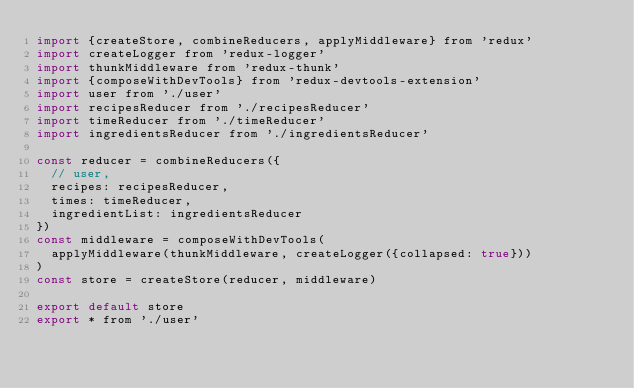Convert code to text. <code><loc_0><loc_0><loc_500><loc_500><_JavaScript_>import {createStore, combineReducers, applyMiddleware} from 'redux'
import createLogger from 'redux-logger'
import thunkMiddleware from 'redux-thunk'
import {composeWithDevTools} from 'redux-devtools-extension'
import user from './user'
import recipesReducer from './recipesReducer'
import timeReducer from './timeReducer'
import ingredientsReducer from './ingredientsReducer'

const reducer = combineReducers({
  // user,
  recipes: recipesReducer,
  times: timeReducer,
  ingredientList: ingredientsReducer
})
const middleware = composeWithDevTools(
  applyMiddleware(thunkMiddleware, createLogger({collapsed: true}))
)
const store = createStore(reducer, middleware)

export default store
export * from './user'
</code> 